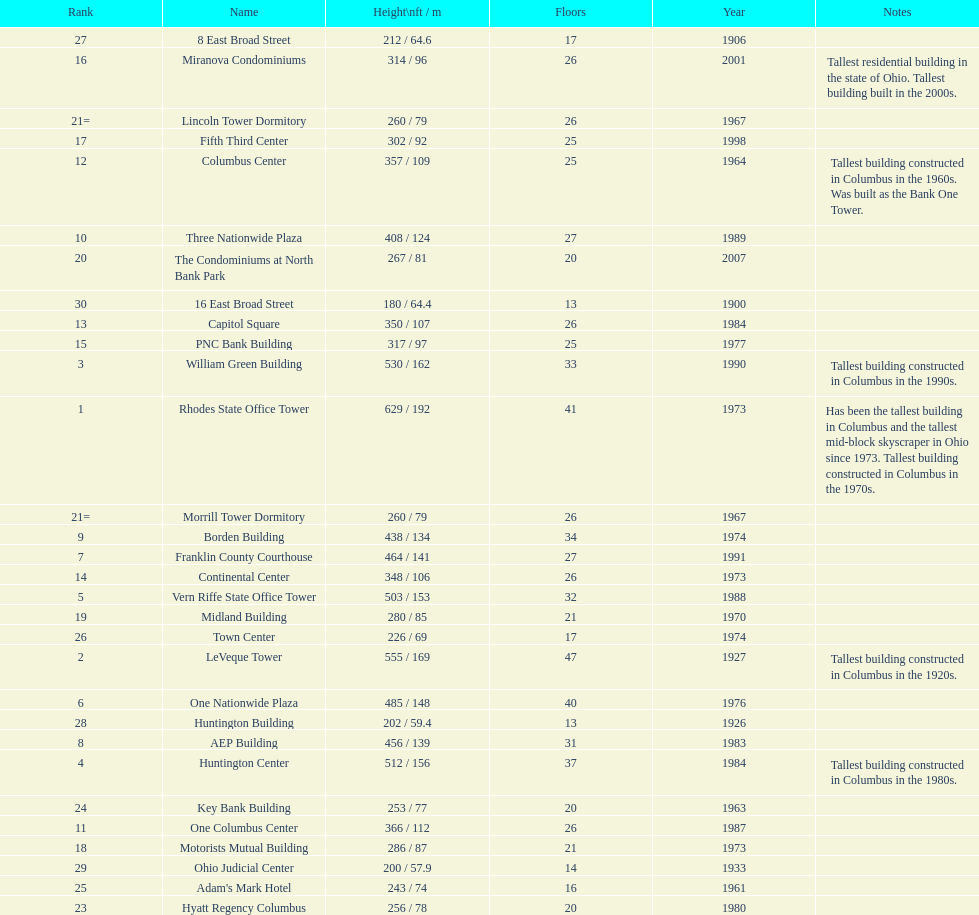Which buildings are taller than 500 ft? Rhodes State Office Tower, LeVeque Tower, William Green Building, Huntington Center, Vern Riffe State Office Tower. Parse the full table. {'header': ['Rank', 'Name', 'Height\\nft / m', 'Floors', 'Year', 'Notes'], 'rows': [['27', '8 East Broad Street', '212 / 64.6', '17', '1906', ''], ['16', 'Miranova Condominiums', '314 / 96', '26', '2001', 'Tallest residential building in the state of Ohio. Tallest building built in the 2000s.'], ['21=', 'Lincoln Tower Dormitory', '260 / 79', '26', '1967', ''], ['17', 'Fifth Third Center', '302 / 92', '25', '1998', ''], ['12', 'Columbus Center', '357 / 109', '25', '1964', 'Tallest building constructed in Columbus in the 1960s. Was built as the Bank One Tower.'], ['10', 'Three Nationwide Plaza', '408 / 124', '27', '1989', ''], ['20', 'The Condominiums at North Bank Park', '267 / 81', '20', '2007', ''], ['30', '16 East Broad Street', '180 / 64.4', '13', '1900', ''], ['13', 'Capitol Square', '350 / 107', '26', '1984', ''], ['15', 'PNC Bank Building', '317 / 97', '25', '1977', ''], ['3', 'William Green Building', '530 / 162', '33', '1990', 'Tallest building constructed in Columbus in the 1990s.'], ['1', 'Rhodes State Office Tower', '629 / 192', '41', '1973', 'Has been the tallest building in Columbus and the tallest mid-block skyscraper in Ohio since 1973. Tallest building constructed in Columbus in the 1970s.'], ['21=', 'Morrill Tower Dormitory', '260 / 79', '26', '1967', ''], ['9', 'Borden Building', '438 / 134', '34', '1974', ''], ['7', 'Franklin County Courthouse', '464 / 141', '27', '1991', ''], ['14', 'Continental Center', '348 / 106', '26', '1973', ''], ['5', 'Vern Riffe State Office Tower', '503 / 153', '32', '1988', ''], ['19', 'Midland Building', '280 / 85', '21', '1970', ''], ['26', 'Town Center', '226 / 69', '17', '1974', ''], ['2', 'LeVeque Tower', '555 / 169', '47', '1927', 'Tallest building constructed in Columbus in the 1920s.'], ['6', 'One Nationwide Plaza', '485 / 148', '40', '1976', ''], ['28', 'Huntington Building', '202 / 59.4', '13', '1926', ''], ['8', 'AEP Building', '456 / 139', '31', '1983', ''], ['4', 'Huntington Center', '512 / 156', '37', '1984', 'Tallest building constructed in Columbus in the 1980s.'], ['24', 'Key Bank Building', '253 / 77', '20', '1963', ''], ['11', 'One Columbus Center', '366 / 112', '26', '1987', ''], ['18', 'Motorists Mutual Building', '286 / 87', '21', '1973', ''], ['29', 'Ohio Judicial Center', '200 / 57.9', '14', '1933', ''], ['25', "Adam's Mark Hotel", '243 / 74', '16', '1961', ''], ['23', 'Hyatt Regency Columbus', '256 / 78', '20', '1980', '']]} 